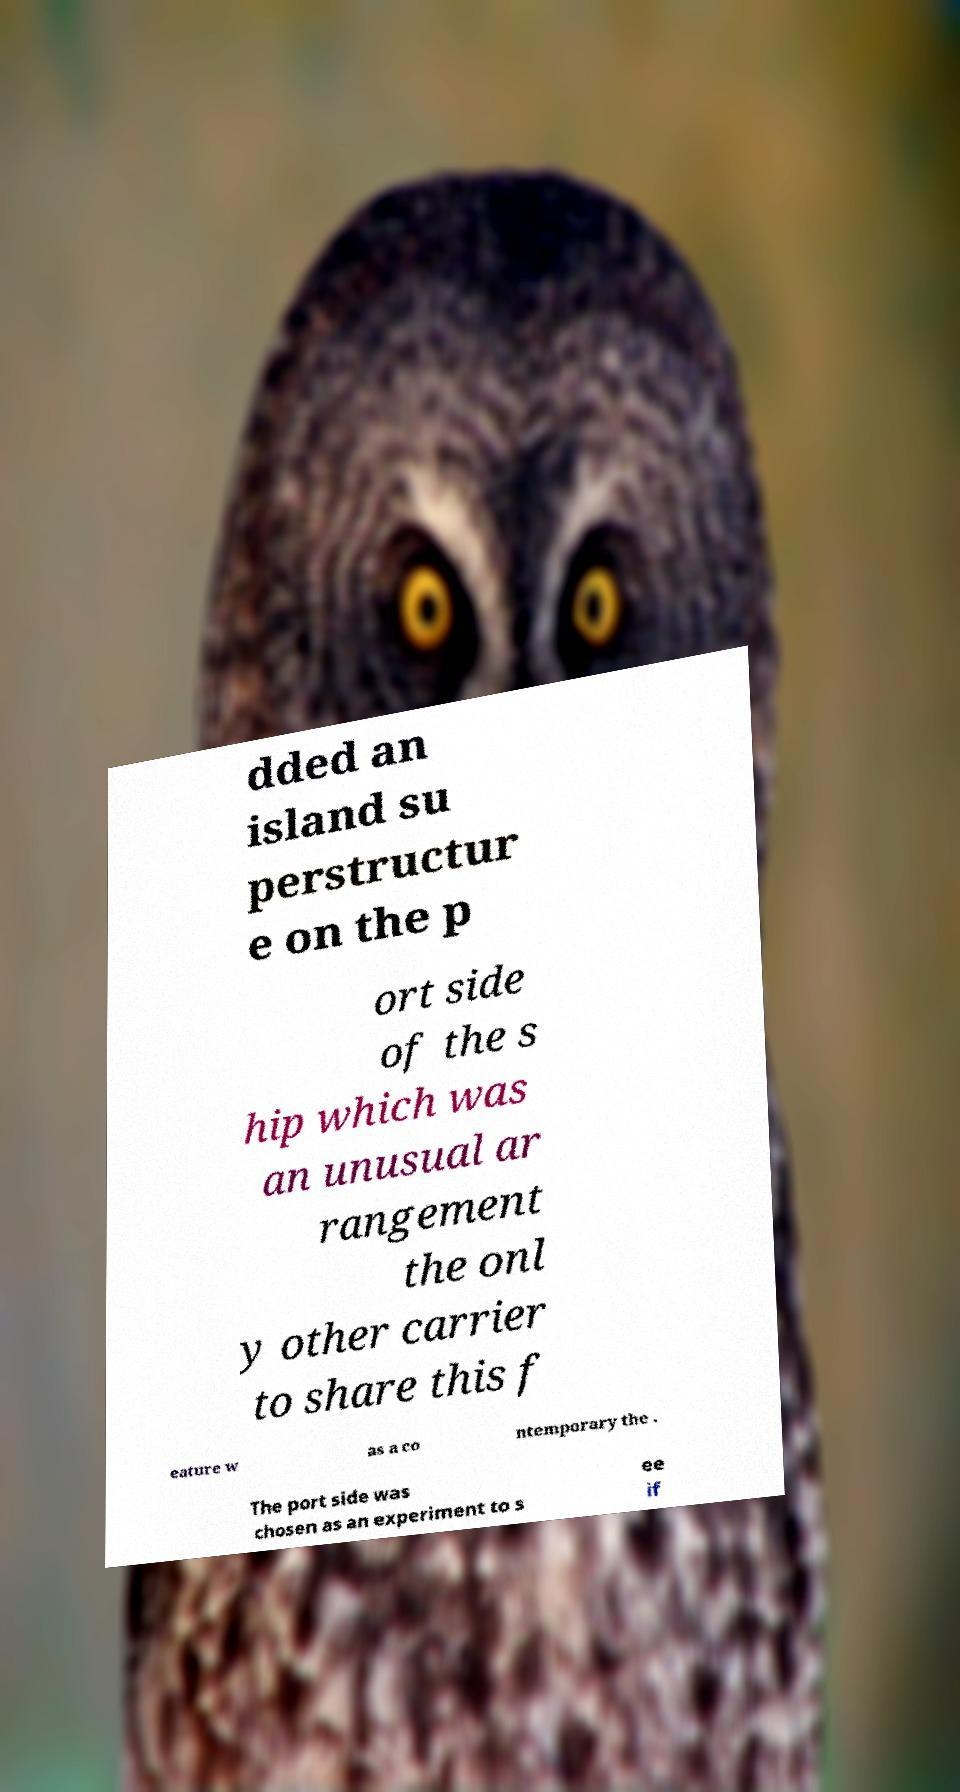For documentation purposes, I need the text within this image transcribed. Could you provide that? dded an island su perstructur e on the p ort side of the s hip which was an unusual ar rangement the onl y other carrier to share this f eature w as a co ntemporary the . The port side was chosen as an experiment to s ee if 